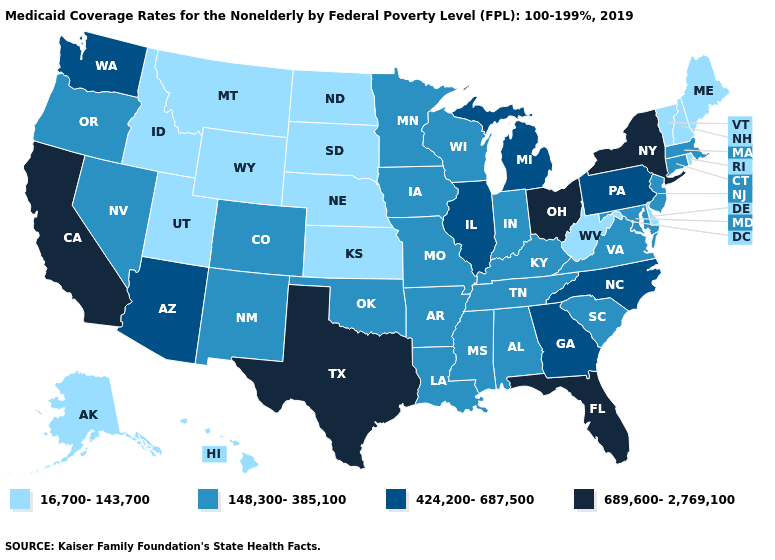Does Delaware have the lowest value in the USA?
Give a very brief answer. Yes. Name the states that have a value in the range 689,600-2,769,100?
Be succinct. California, Florida, New York, Ohio, Texas. Does North Carolina have the highest value in the South?
Give a very brief answer. No. How many symbols are there in the legend?
Keep it brief. 4. Name the states that have a value in the range 148,300-385,100?
Be succinct. Alabama, Arkansas, Colorado, Connecticut, Indiana, Iowa, Kentucky, Louisiana, Maryland, Massachusetts, Minnesota, Mississippi, Missouri, Nevada, New Jersey, New Mexico, Oklahoma, Oregon, South Carolina, Tennessee, Virginia, Wisconsin. Among the states that border Mississippi , which have the highest value?
Concise answer only. Alabama, Arkansas, Louisiana, Tennessee. Name the states that have a value in the range 689,600-2,769,100?
Write a very short answer. California, Florida, New York, Ohio, Texas. Among the states that border New York , does Connecticut have the lowest value?
Answer briefly. No. Which states have the lowest value in the South?
Short answer required. Delaware, West Virginia. Does Ohio have the highest value in the USA?
Quick response, please. Yes. Does North Dakota have the lowest value in the USA?
Short answer required. Yes. What is the value of Massachusetts?
Short answer required. 148,300-385,100. Does Arkansas have a higher value than South Dakota?
Answer briefly. Yes. Does Arizona have the lowest value in the USA?
Answer briefly. No. 